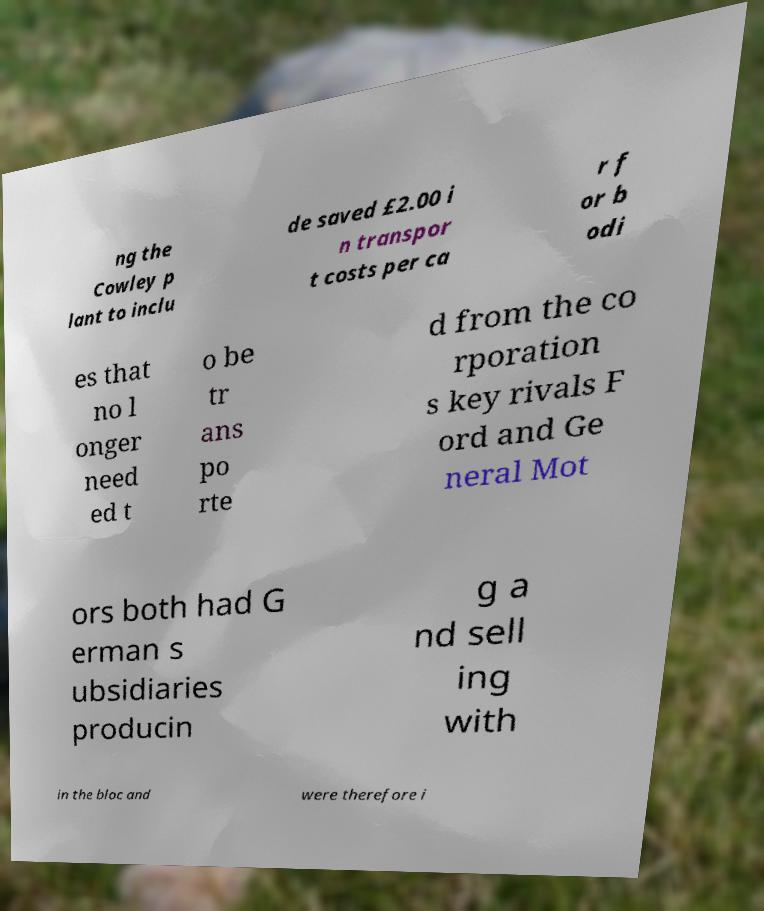For documentation purposes, I need the text within this image transcribed. Could you provide that? ng the Cowley p lant to inclu de saved £2.00 i n transpor t costs per ca r f or b odi es that no l onger need ed t o be tr ans po rte d from the co rporation s key rivals F ord and Ge neral Mot ors both had G erman s ubsidiaries producin g a nd sell ing with in the bloc and were therefore i 